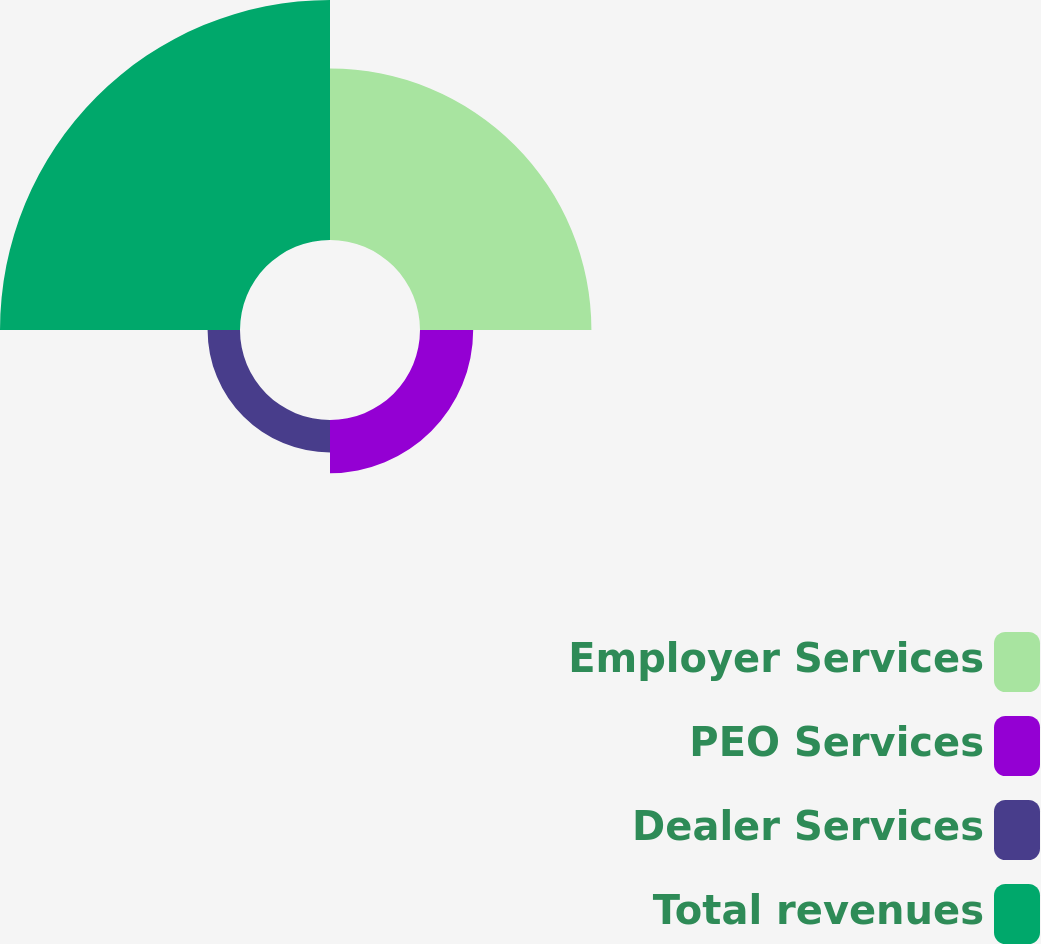<chart> <loc_0><loc_0><loc_500><loc_500><pie_chart><fcel>Employer Services<fcel>PEO Services<fcel>Dealer Services<fcel>Total revenues<nl><fcel>34.49%<fcel>10.7%<fcel>6.52%<fcel>48.29%<nl></chart> 